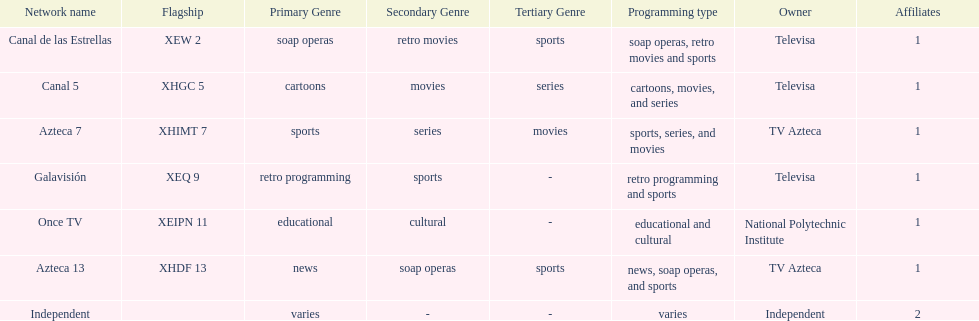Name a station that shows sports but is not televisa. Azteca 7. 